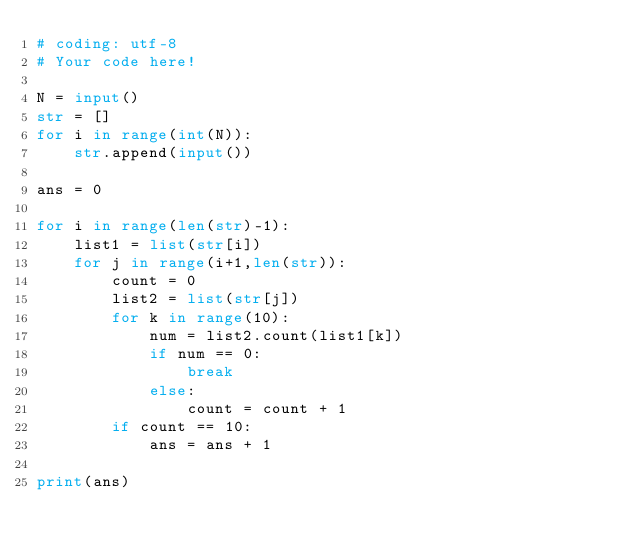Convert code to text. <code><loc_0><loc_0><loc_500><loc_500><_Python_># coding: utf-8
# Your code here!

N = input()
str = []
for i in range(int(N)):
    str.append(input())

ans = 0

for i in range(len(str)-1):
    list1 = list(str[i])
    for j in range(i+1,len(str)):
        count = 0
        list2 = list(str[j])
        for k in range(10):
            num = list2.count(list1[k])
            if num == 0:
                break
            else:
                count = count + 1
        if count == 10:
            ans = ans + 1
        
print(ans)

</code> 